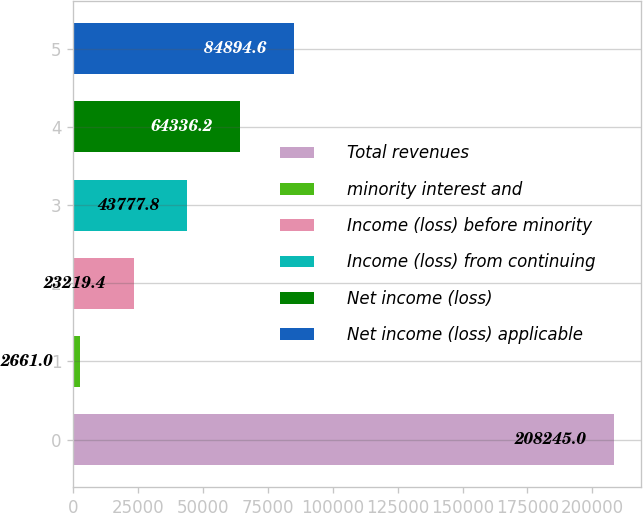Convert chart to OTSL. <chart><loc_0><loc_0><loc_500><loc_500><bar_chart><fcel>Total revenues<fcel>minority interest and<fcel>Income (loss) before minority<fcel>Income (loss) from continuing<fcel>Net income (loss)<fcel>Net income (loss) applicable<nl><fcel>208245<fcel>2661<fcel>23219.4<fcel>43777.8<fcel>64336.2<fcel>84894.6<nl></chart> 